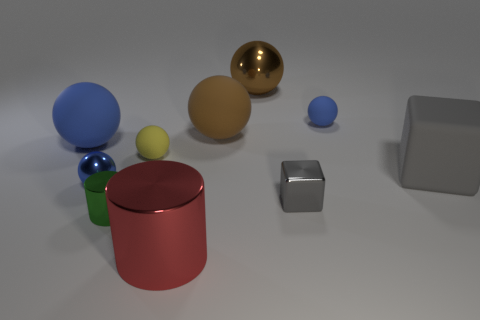Subtract all blue balls. How many were subtracted if there are1blue balls left? 2 Subtract all brown cubes. How many blue balls are left? 3 Subtract all rubber balls. How many balls are left? 2 Subtract all yellow balls. How many balls are left? 5 Add 4 metal balls. How many metal balls exist? 6 Subtract 1 red cylinders. How many objects are left? 9 Subtract all cylinders. How many objects are left? 8 Subtract all purple blocks. Subtract all purple balls. How many blocks are left? 2 Subtract all big gray cubes. Subtract all small spheres. How many objects are left? 6 Add 8 large brown metal spheres. How many large brown metal spheres are left? 9 